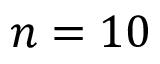<formula> <loc_0><loc_0><loc_500><loc_500>n = 1 0</formula> 